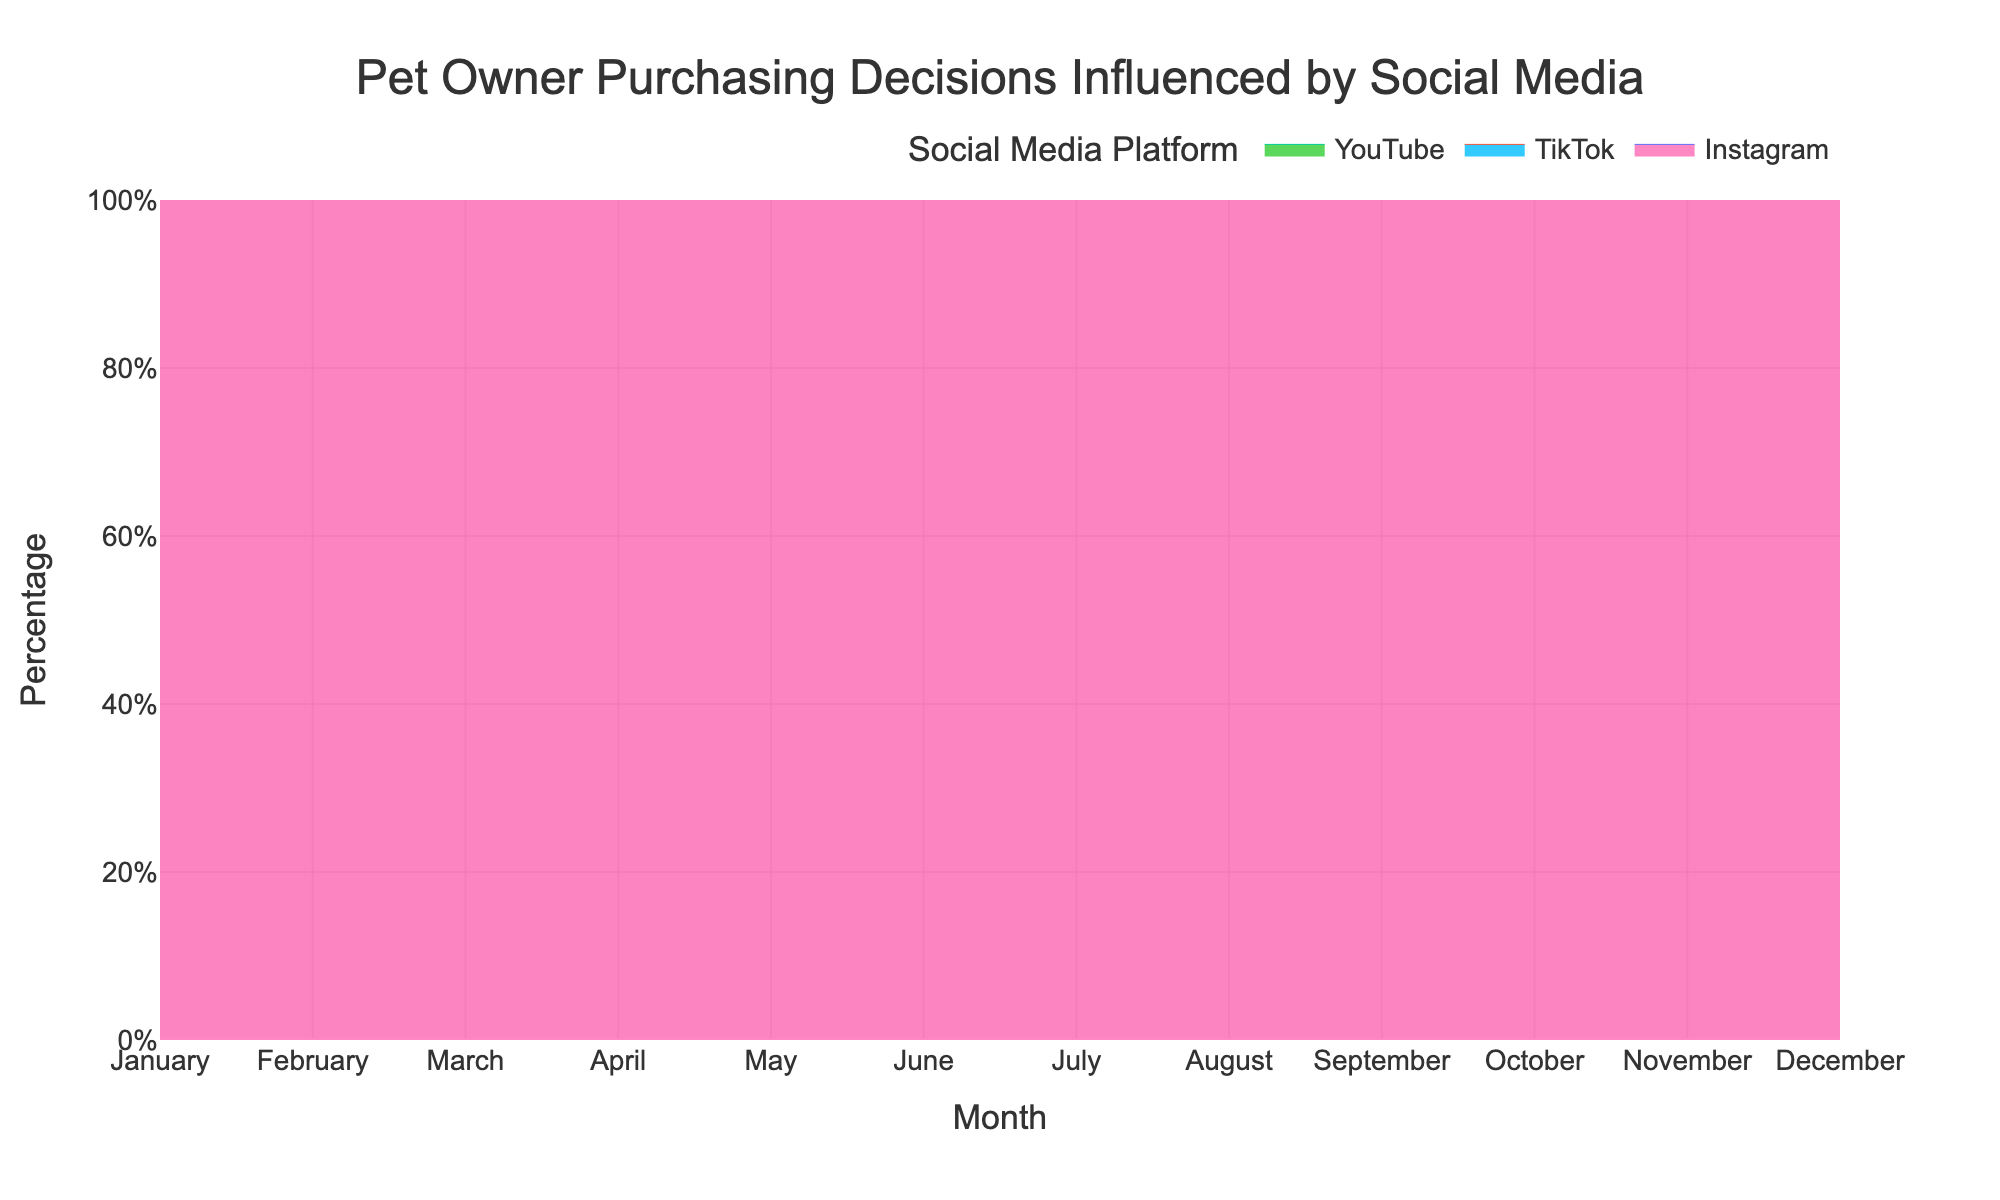How does the title describe the chart? The title "Pet Owner Purchasing Decisions Influenced by Social Media" clearly indicates that the chart shows how different social media platforms influence pet owners' purchasing decisions over time.
Answer: Pet Owner Purchasing Decisions Influenced by Social Media Which months show the highest percentage of influence by Instagram? By observing the chart, we can see the areas corresponding to Instagram are highest in November and December.
Answer: November, December What was the overall trend for TikTok's influence from January to December? TikTok's influence started high in January with 35% and gradually decreased to 27% by December, showing a downward trend.
Answer: Downward trend Which platform had the most stable influence percentage over the months? By examining the consistency of the areas, YouTube's influence showed stability hovering around 31-35% throughout the year without extreme fluctuations.
Answer: YouTube What is the combined influence percentage of Instagram and YouTube in June? To find this, add the percentage of influence of Instagram (37%) and YouTube (32%) in June. 37% + 32% = 69%.
Answer: 69% Which platform had the lowest influence in December? In December, TikTok had the lowest influence with only 27%, as depicted by the smallest area at the bottom of the stack.
Answer: TikTok During which month did TikTok and Instagram together make up 65% of the influence? By examining the months, in January, the sum of TikTok’s 35% and Instagram’s 30% equals 65%. 35% + 30% = 65%
Answer: January Compare the influence of Instagram and YouTube in March. Which one had a higher percentage? Looking at March data, Instagram had 33% and YouTube had 33%. Thus, the influence percentages were the same.
Answer: Equal How did the influence of Instagram change from January to December? We see that Instagram’s influence increased from 30% in January to 42% in December, showing an upward trend.
Answer: Increased What is the approximate average influence of YouTube over the twelve months? To calculate the average percentage of YouTube’s influence, add up each month’s percentage and divide by 12: (35+35+33+33+33+32+32+32+32+32+31+31)/12 = 32.67%.
Answer: 32.67% 